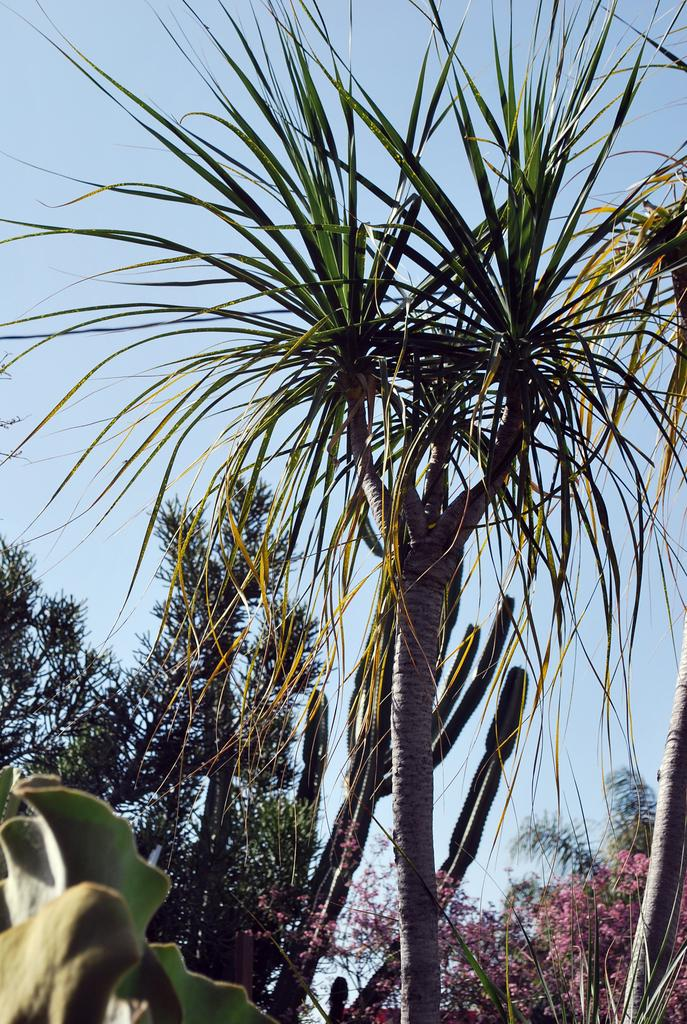What type of vegetation can be seen in the image? There are trees in the image. What other natural elements can be seen in the image? There are flowers in the image. What is visible in the background of the image? The sky is visible in the image. How many dimes are scattered among the flowers in the image? There are no dimes present in the image; it features trees, flowers, and the sky. What type of society is depicted in the image? There is no society depicted in the image; it is a natural scene with trees, flowers, and the sky. 